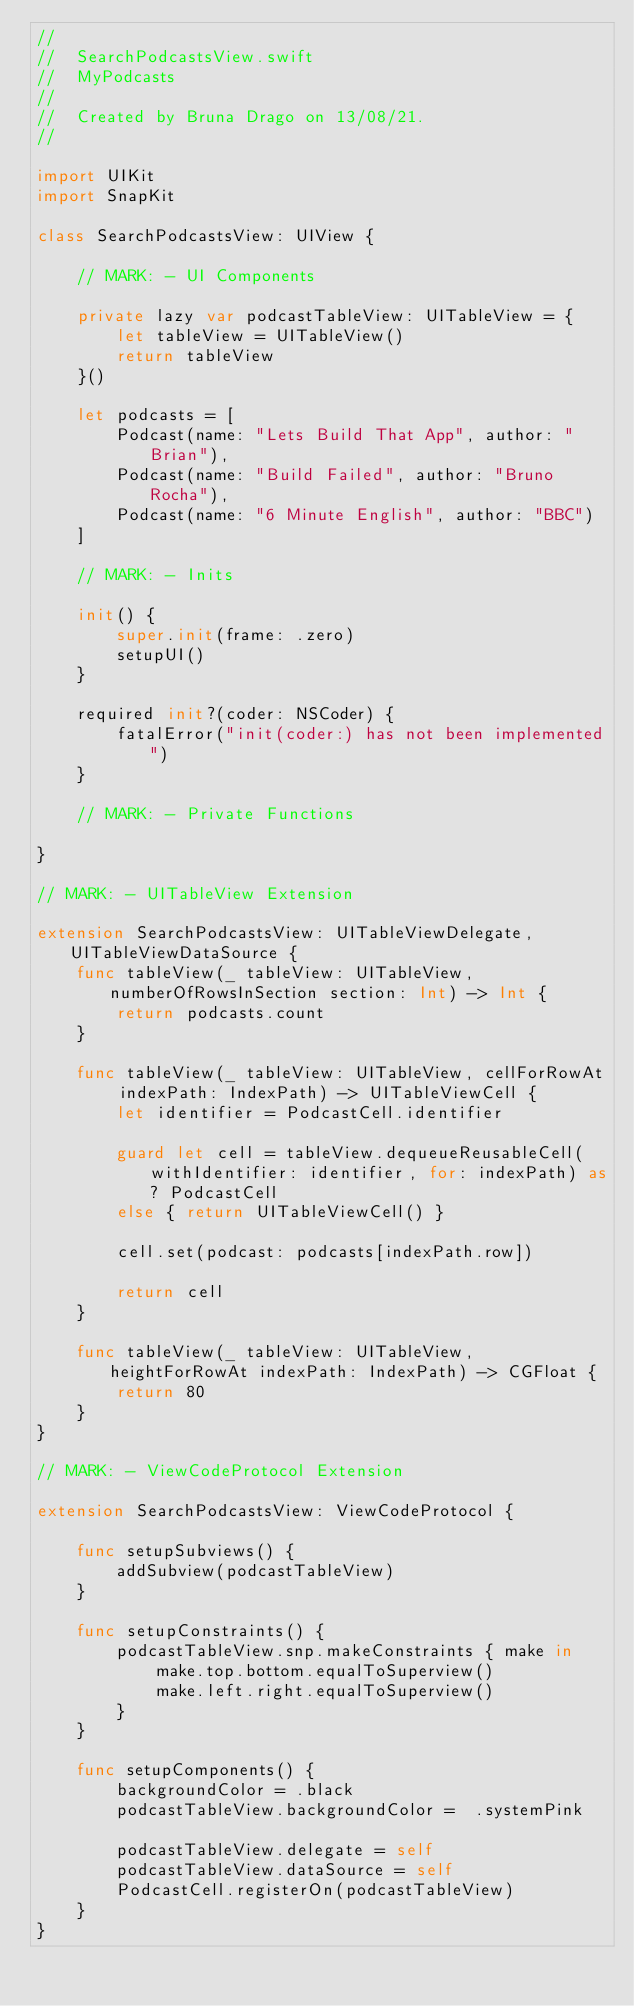<code> <loc_0><loc_0><loc_500><loc_500><_Swift_>//
//  SearchPodcastsView.swift
//  MyPodcasts
//
//  Created by Bruna Drago on 13/08/21.
//

import UIKit
import SnapKit

class SearchPodcastsView: UIView {
    
    // MARK: - UI Components
    
    private lazy var podcastTableView: UITableView = {
        let tableView = UITableView()
        return tableView
    }()
    
    let podcasts = [
        Podcast(name: "Lets Build That App", author: "Brian"),
        Podcast(name: "Build Failed", author: "Bruno Rocha"),
        Podcast(name: "6 Minute English", author: "BBC")
    ]
    
    // MARK: - Inits
    
    init() {
        super.init(frame: .zero)
        setupUI()
    }
    
    required init?(coder: NSCoder) {
        fatalError("init(coder:) has not been implemented")
    }
    
    // MARK: - Private Functions
    
}

// MARK: - UITableView Extension

extension SearchPodcastsView: UITableViewDelegate, UITableViewDataSource {
    func tableView(_ tableView: UITableView, numberOfRowsInSection section: Int) -> Int {
        return podcasts.count
    }
    
    func tableView(_ tableView: UITableView, cellForRowAt indexPath: IndexPath) -> UITableViewCell {
        let identifier = PodcastCell.identifier
        
        guard let cell = tableView.dequeueReusableCell(withIdentifier: identifier, for: indexPath) as? PodcastCell
        else { return UITableViewCell() }
        
        cell.set(podcast: podcasts[indexPath.row])
        
        return cell
    }
    
    func tableView(_ tableView: UITableView, heightForRowAt indexPath: IndexPath) -> CGFloat {
        return 80
    }
}

// MARK: - ViewCodeProtocol Extension

extension SearchPodcastsView: ViewCodeProtocol {
    
    func setupSubviews() {
        addSubview(podcastTableView)
    }
    
    func setupConstraints() {
        podcastTableView.snp.makeConstraints { make in
            make.top.bottom.equalToSuperview()
            make.left.right.equalToSuperview()
        }
    }
    
    func setupComponents() {
        backgroundColor = .black
        podcastTableView.backgroundColor =  .systemPink
        
        podcastTableView.delegate = self
        podcastTableView.dataSource = self
        PodcastCell.registerOn(podcastTableView)
    }
}
</code> 